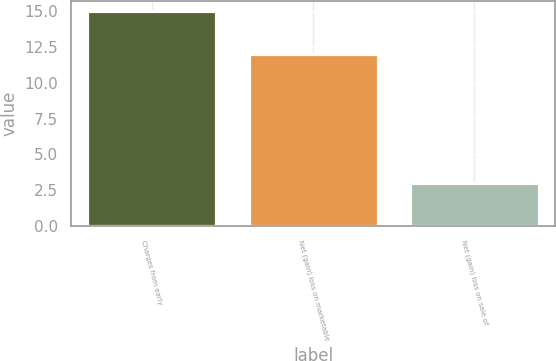Convert chart. <chart><loc_0><loc_0><loc_500><loc_500><bar_chart><fcel>Charges from early<fcel>Net (gain) loss on marketable<fcel>Net (gain) loss on sale of<nl><fcel>15<fcel>12<fcel>3<nl></chart> 